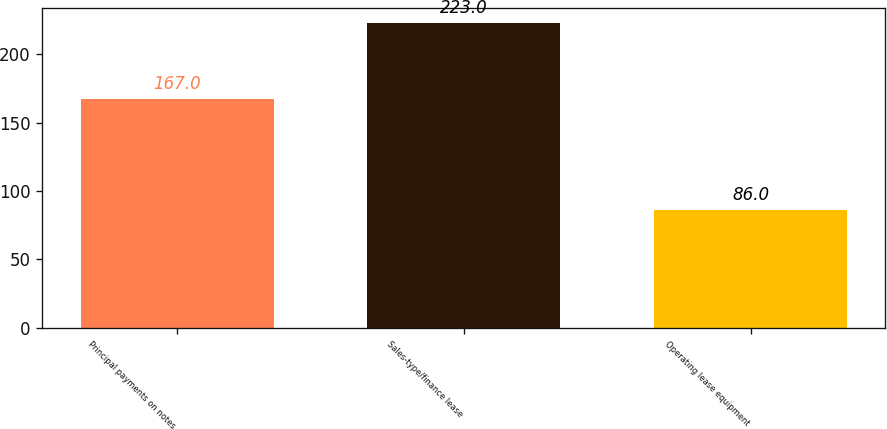Convert chart to OTSL. <chart><loc_0><loc_0><loc_500><loc_500><bar_chart><fcel>Principal payments on notes<fcel>Sales-type/finance lease<fcel>Operating lease equipment<nl><fcel>167<fcel>223<fcel>86<nl></chart> 